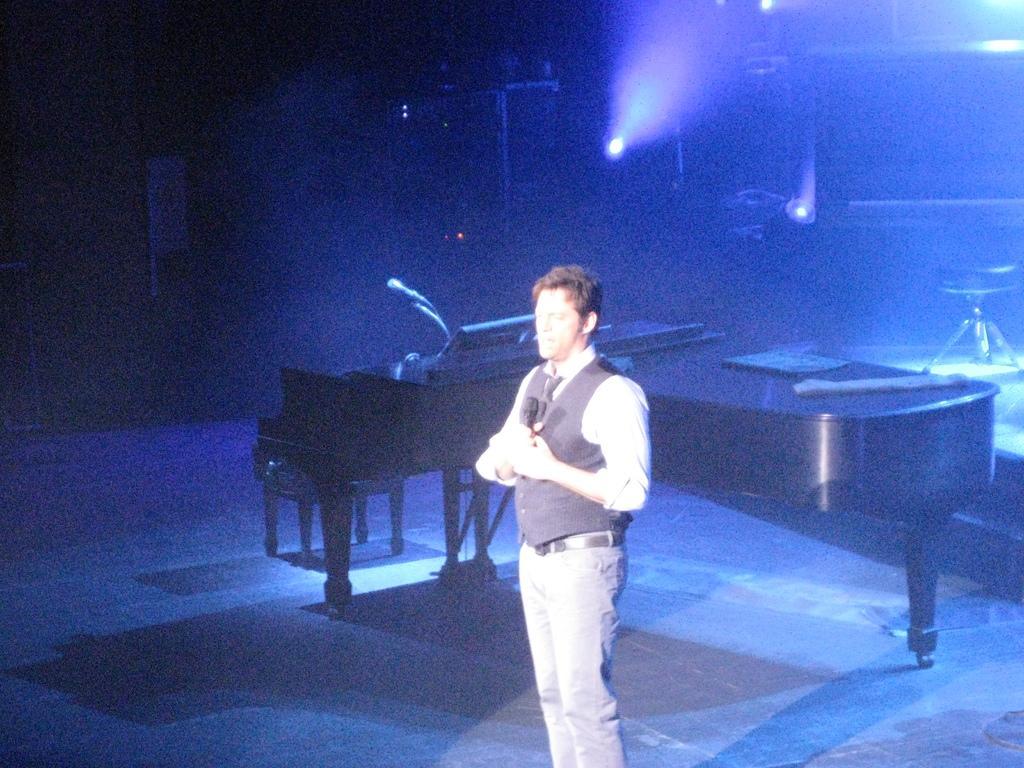Describe this image in one or two sentences. In this picture there is a person standing and holding the microphone. At the back there are musical instruments and there is a stool and there are lights and there is a microphone and there are objects on the musical instruments. 